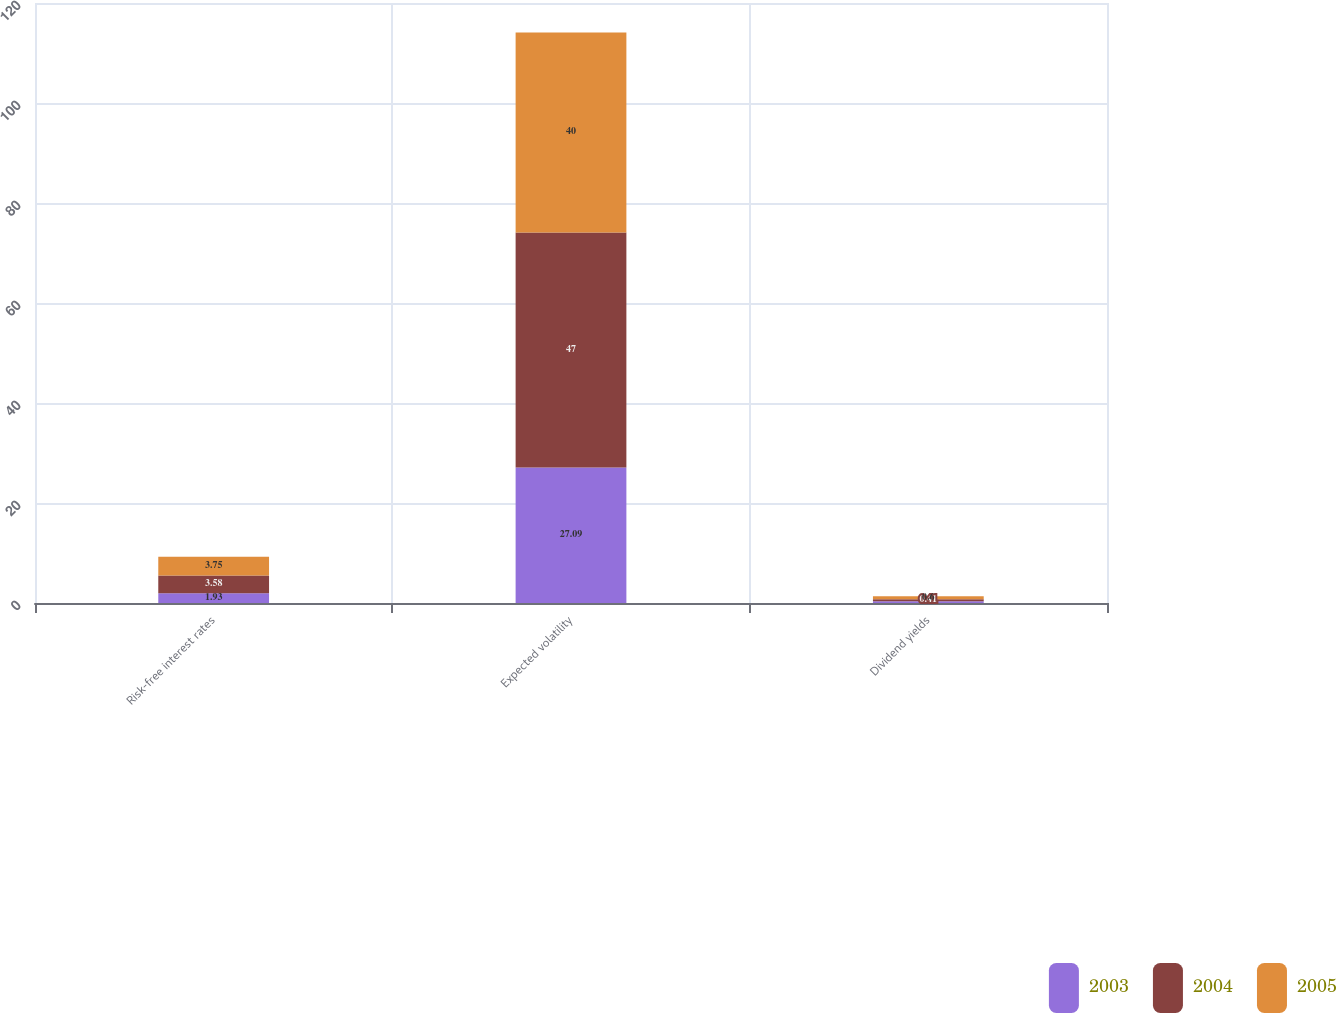Convert chart to OTSL. <chart><loc_0><loc_0><loc_500><loc_500><stacked_bar_chart><ecel><fcel>Risk-free interest rates<fcel>Expected volatility<fcel>Dividend yields<nl><fcel>2003<fcel>1.93<fcel>27.09<fcel>0.34<nl><fcel>2004<fcel>3.58<fcel>47<fcel>0.41<nl><fcel>2005<fcel>3.75<fcel>40<fcel>0.6<nl></chart> 